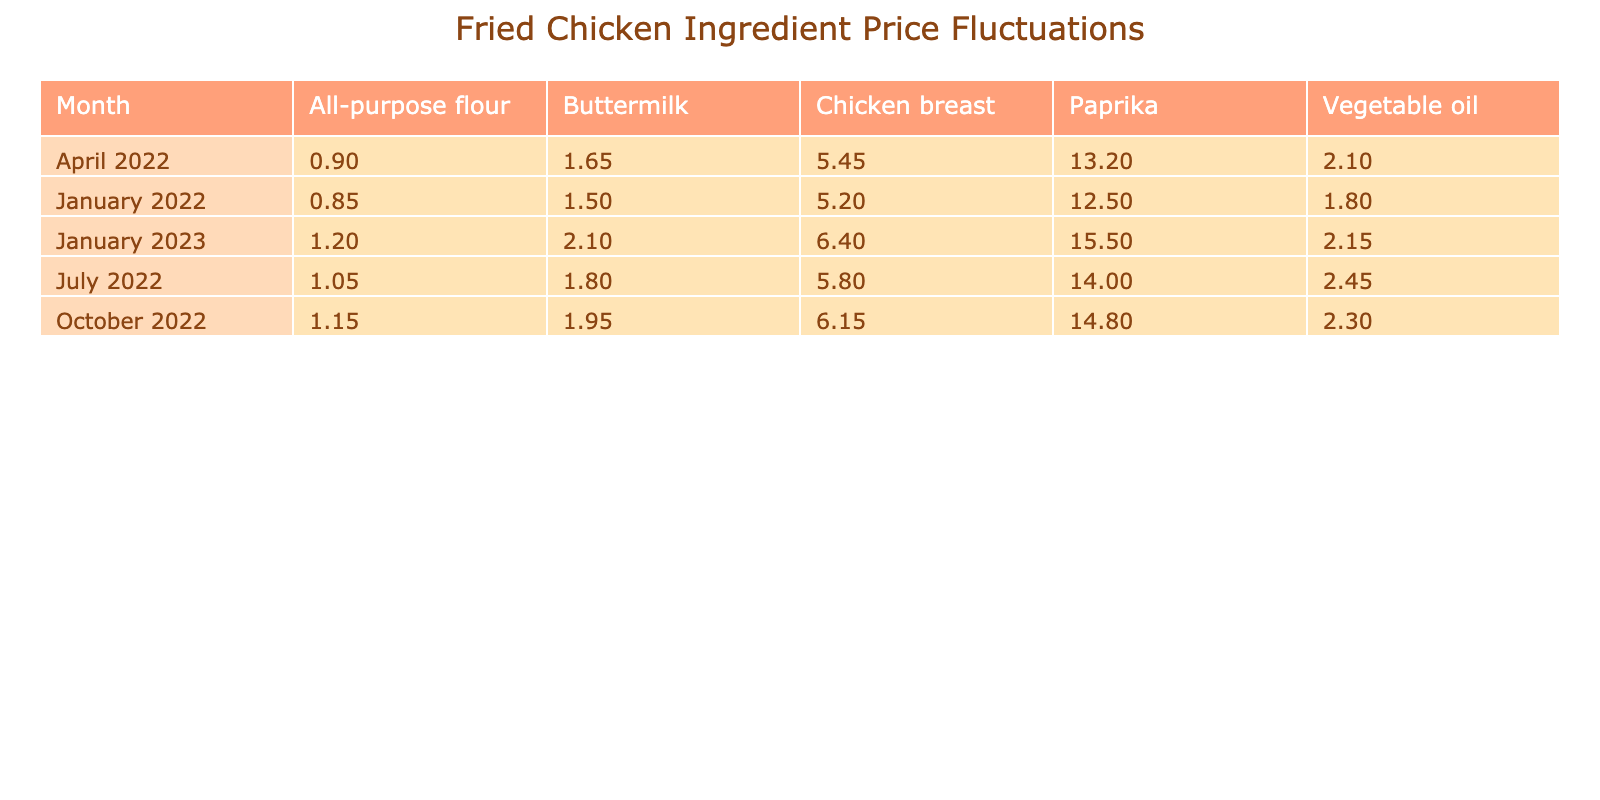What was the price of chicken breast in October 2022? The table shows the price of chicken breast for each month. Referring specifically to October 2022, the price of chicken breast is listed as 6.15 GBP per kg.
Answer: 6.15 GBP Which ingredient had the highest price in January 2023? Looking at the prices in January 2023, we see chicken breast at 6.40, vegetable oil at 2.15, all-purpose flour at 1.20, buttermilk at 2.10, and paprika at 15.50. Paprika has the highest price of 15.50 GBP per kg.
Answer: Paprika How much did the price of all-purpose flour increase from January 2022 to January 2023? The price of all-purpose flour in January 2022 was 0.85, and in January 2023 it was 1.20. The increase is calculated as 1.20 - 0.85 = 0.35.
Answer: 0.35 GBP Did the price of vegetable oil decrease from July 2022 to January 2023? The price of vegetable oil in July 2022 was 2.45 and in January 2023 it was 2.15. Since 2.15 is less than 2.45, the price did decrease.
Answer: Yes What is the average price of chicken breast across the listed months? The prices for chicken breast are 5.20, 5.45, 5.80, 6.15, and 6.40. The total is 28.00, and there are 5 data points, so the average is 28.00 / 5 = 5.60.
Answer: 5.60 GBP Which ingredient had the least price fluctuation from January 2022 to January 2023? To determine fluctuation, we compare the price changes for all ingredients over the period. Chicken breast increased by 1.20, vegetable oil decreased by 0.65, all-purpose flour increased by 0.35, buttermilk increased by 0.60, and paprika increased by 3.00. The smallest increase is for all-purpose flour, which fluctuated by 0.35 GBP.
Answer: All-purpose flour By how much did paprika's price change over the year from January 2022 to January 2023? The price of paprika in January 2022 was 12.50 and in January 2023 it was 15.50. The change is calculated as 15.50 - 12.50 = 3.00.
Answer: 3.00 GBP What was the overall trend for buttermilk prices throughout the year? The prices for buttermilk were 1.50, 1.65, 1.80, 1.95, and 2.10, which all show an upward trend as the prices continuously increased each quarter.
Answer: Upward trend What is the sum of the prices of all ingredients in April 2022? The prices in April 2022 are chicken breast at 5.45, vegetable oil at 2.10, all-purpose flour at 0.90, buttermilk at 1.65, and paprika at 13.20. The sum is 5.45 + 2.10 + 0.90 + 1.65 + 13.20 = 23.30.
Answer: 23.30 GBP Was there any month where the price of chicken breast was lower than the price of paprika? The price of chicken breast for all months is compared to the price of paprika in the same months. The prices of chicken breast were lower than paprika in every instance, confirming the query.
Answer: Yes 